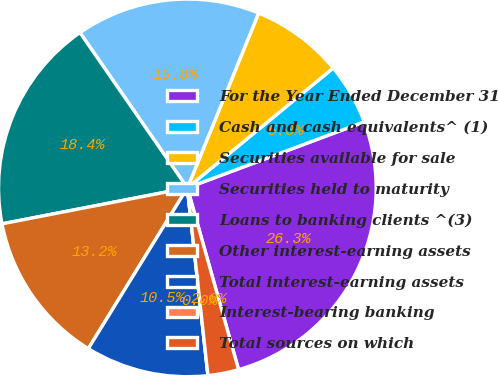Convert chart to OTSL. <chart><loc_0><loc_0><loc_500><loc_500><pie_chart><fcel>For the Year Ended December 31<fcel>Cash and cash equivalents^ (1)<fcel>Securities available for sale<fcel>Securities held to maturity<fcel>Loans to banking clients ^(3)<fcel>Other interest-earning assets<fcel>Total interest-earning assets<fcel>Interest-bearing banking<fcel>Total sources on which<nl><fcel>26.32%<fcel>5.26%<fcel>7.89%<fcel>15.79%<fcel>18.42%<fcel>13.16%<fcel>10.53%<fcel>0.0%<fcel>2.63%<nl></chart> 